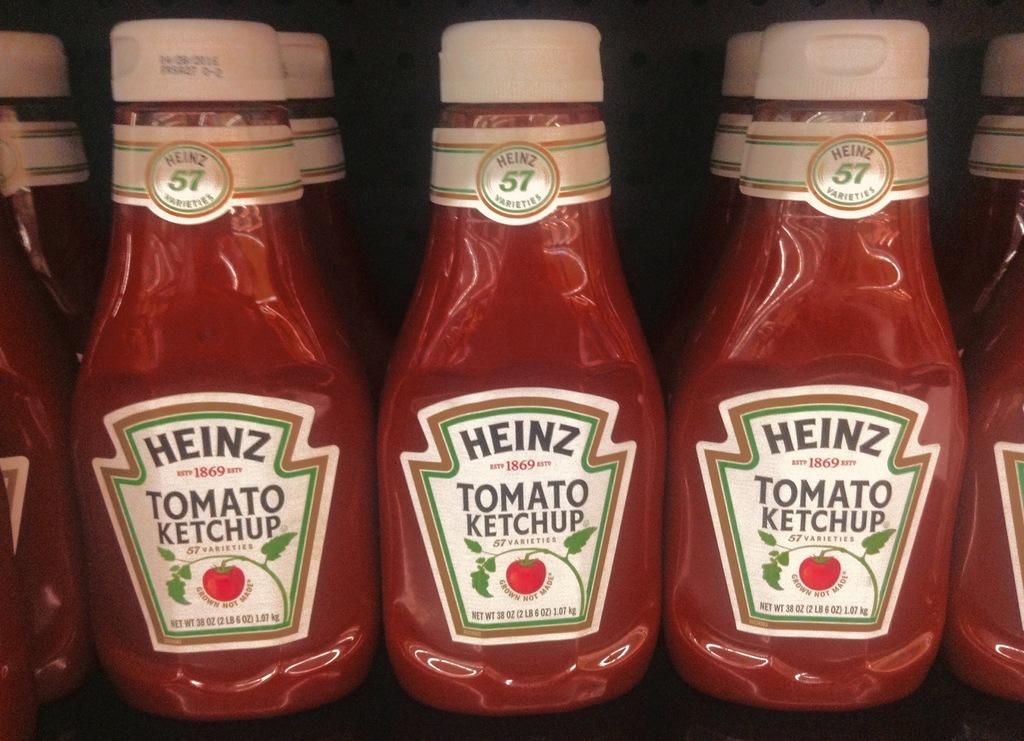What type of condiment is featured in the image? There are ketchup bottles in the image. How are the ketchup bottles arranged? The ketchup bottles are arranged in an order. What can be observed about the background of the image? The background of the image is dark. What type of crate is visible in the image? There is no crate present in the image. Can you tell me how many insects are crawling on the ketchup bottles? There are no insects present on the ketchup bottles in the image. 